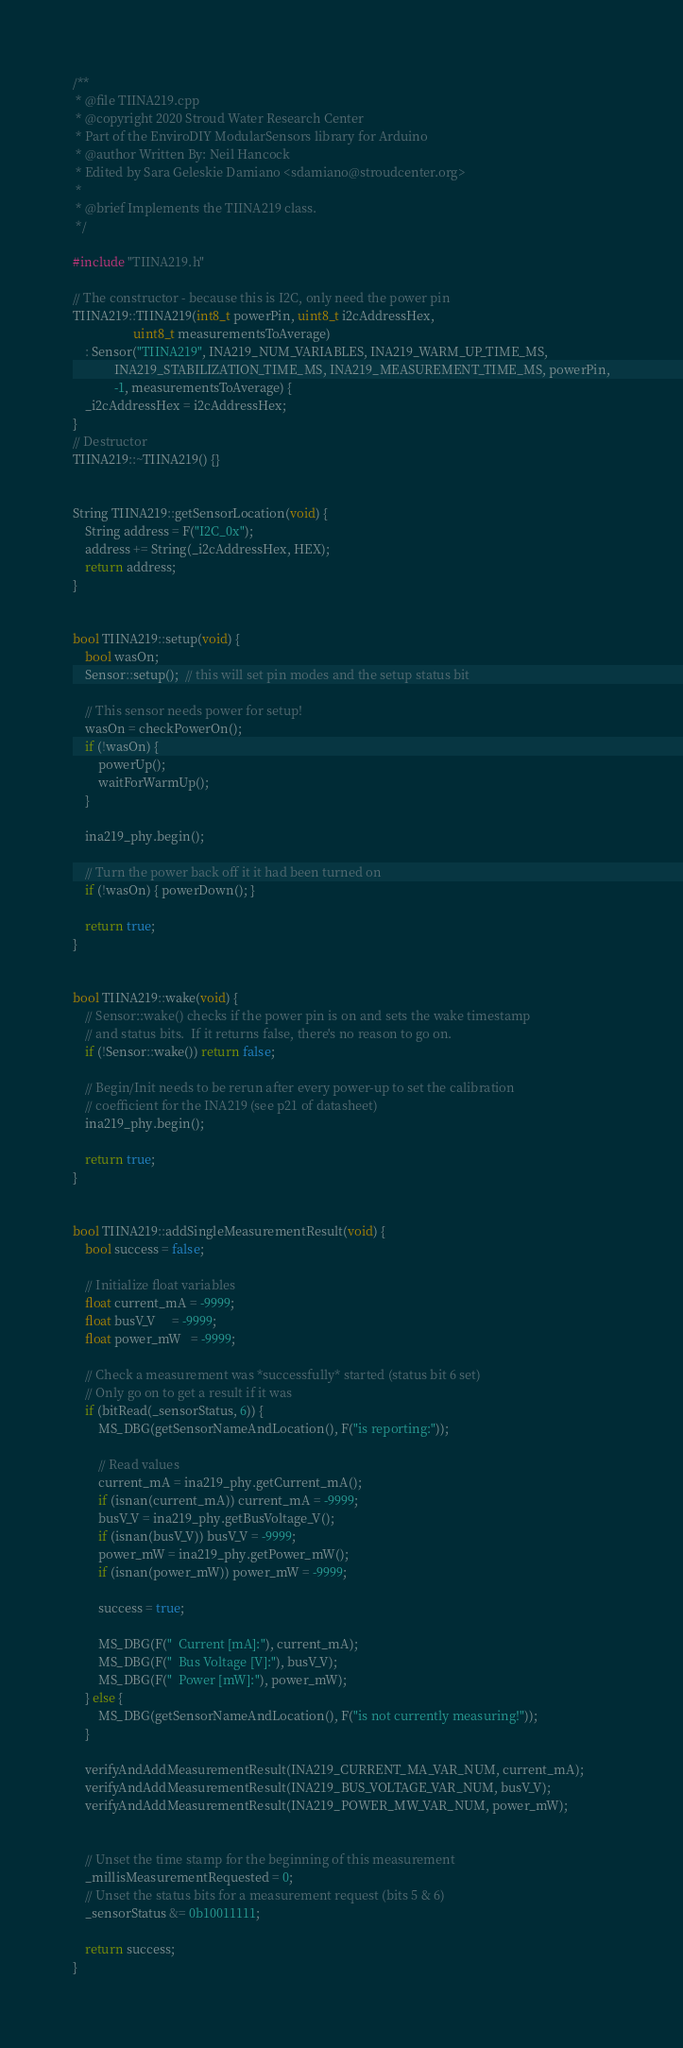<code> <loc_0><loc_0><loc_500><loc_500><_C++_>/**
 * @file TIINA219.cpp
 * @copyright 2020 Stroud Water Research Center
 * Part of the EnviroDIY ModularSensors library for Arduino
 * @author Written By: Neil Hancock
 * Edited by Sara Geleskie Damiano <sdamiano@stroudcenter.org>
 *
 * @brief Implements the TIINA219 class.
 */

#include "TIINA219.h"

// The constructor - because this is I2C, only need the power pin
TIINA219::TIINA219(int8_t powerPin, uint8_t i2cAddressHex,
                   uint8_t measurementsToAverage)
    : Sensor("TIINA219", INA219_NUM_VARIABLES, INA219_WARM_UP_TIME_MS,
             INA219_STABILIZATION_TIME_MS, INA219_MEASUREMENT_TIME_MS, powerPin,
             -1, measurementsToAverage) {
    _i2cAddressHex = i2cAddressHex;
}
// Destructor
TIINA219::~TIINA219() {}


String TIINA219::getSensorLocation(void) {
    String address = F("I2C_0x");
    address += String(_i2cAddressHex, HEX);
    return address;
}


bool TIINA219::setup(void) {
    bool wasOn;
    Sensor::setup();  // this will set pin modes and the setup status bit

    // This sensor needs power for setup!
    wasOn = checkPowerOn();
    if (!wasOn) {
        powerUp();
        waitForWarmUp();
    }

    ina219_phy.begin();

    // Turn the power back off it it had been turned on
    if (!wasOn) { powerDown(); }

    return true;
}


bool TIINA219::wake(void) {
    // Sensor::wake() checks if the power pin is on and sets the wake timestamp
    // and status bits.  If it returns false, there's no reason to go on.
    if (!Sensor::wake()) return false;

    // Begin/Init needs to be rerun after every power-up to set the calibration
    // coefficient for the INA219 (see p21 of datasheet)
    ina219_phy.begin();

    return true;
}


bool TIINA219::addSingleMeasurementResult(void) {
    bool success = false;

    // Initialize float variables
    float current_mA = -9999;
    float busV_V     = -9999;
    float power_mW   = -9999;

    // Check a measurement was *successfully* started (status bit 6 set)
    // Only go on to get a result if it was
    if (bitRead(_sensorStatus, 6)) {
        MS_DBG(getSensorNameAndLocation(), F("is reporting:"));

        // Read values
        current_mA = ina219_phy.getCurrent_mA();
        if (isnan(current_mA)) current_mA = -9999;
        busV_V = ina219_phy.getBusVoltage_V();
        if (isnan(busV_V)) busV_V = -9999;
        power_mW = ina219_phy.getPower_mW();
        if (isnan(power_mW)) power_mW = -9999;

        success = true;

        MS_DBG(F("  Current [mA]:"), current_mA);
        MS_DBG(F("  Bus Voltage [V]:"), busV_V);
        MS_DBG(F("  Power [mW]:"), power_mW);
    } else {
        MS_DBG(getSensorNameAndLocation(), F("is not currently measuring!"));
    }

    verifyAndAddMeasurementResult(INA219_CURRENT_MA_VAR_NUM, current_mA);
    verifyAndAddMeasurementResult(INA219_BUS_VOLTAGE_VAR_NUM, busV_V);
    verifyAndAddMeasurementResult(INA219_POWER_MW_VAR_NUM, power_mW);


    // Unset the time stamp for the beginning of this measurement
    _millisMeasurementRequested = 0;
    // Unset the status bits for a measurement request (bits 5 & 6)
    _sensorStatus &= 0b10011111;

    return success;
}
</code> 